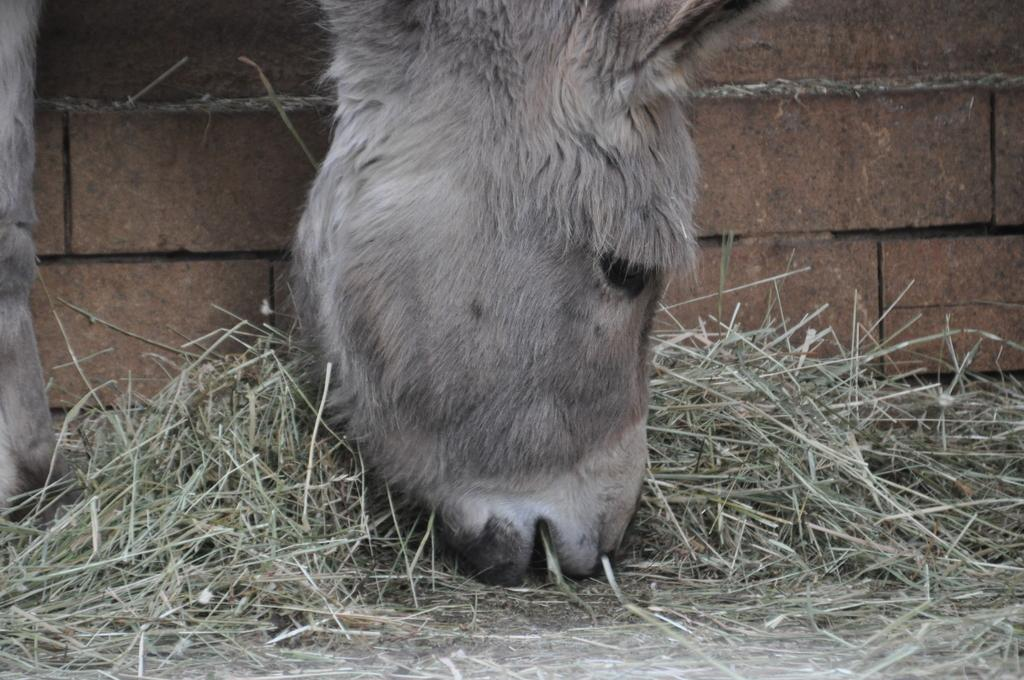What type of animal can be seen in the image? There is an animal in the image. What is the animal doing in the image? The animal is eating grass. Where is the grass located in the image? The grass is on the ground. What can be seen in the background of the image? There is a wall and a rope in the background of the image. What time of day is it in the image, given the presence of a cemetery? There is no cemetery present in the image, so it is not possible to determine the time of day based on that information. 